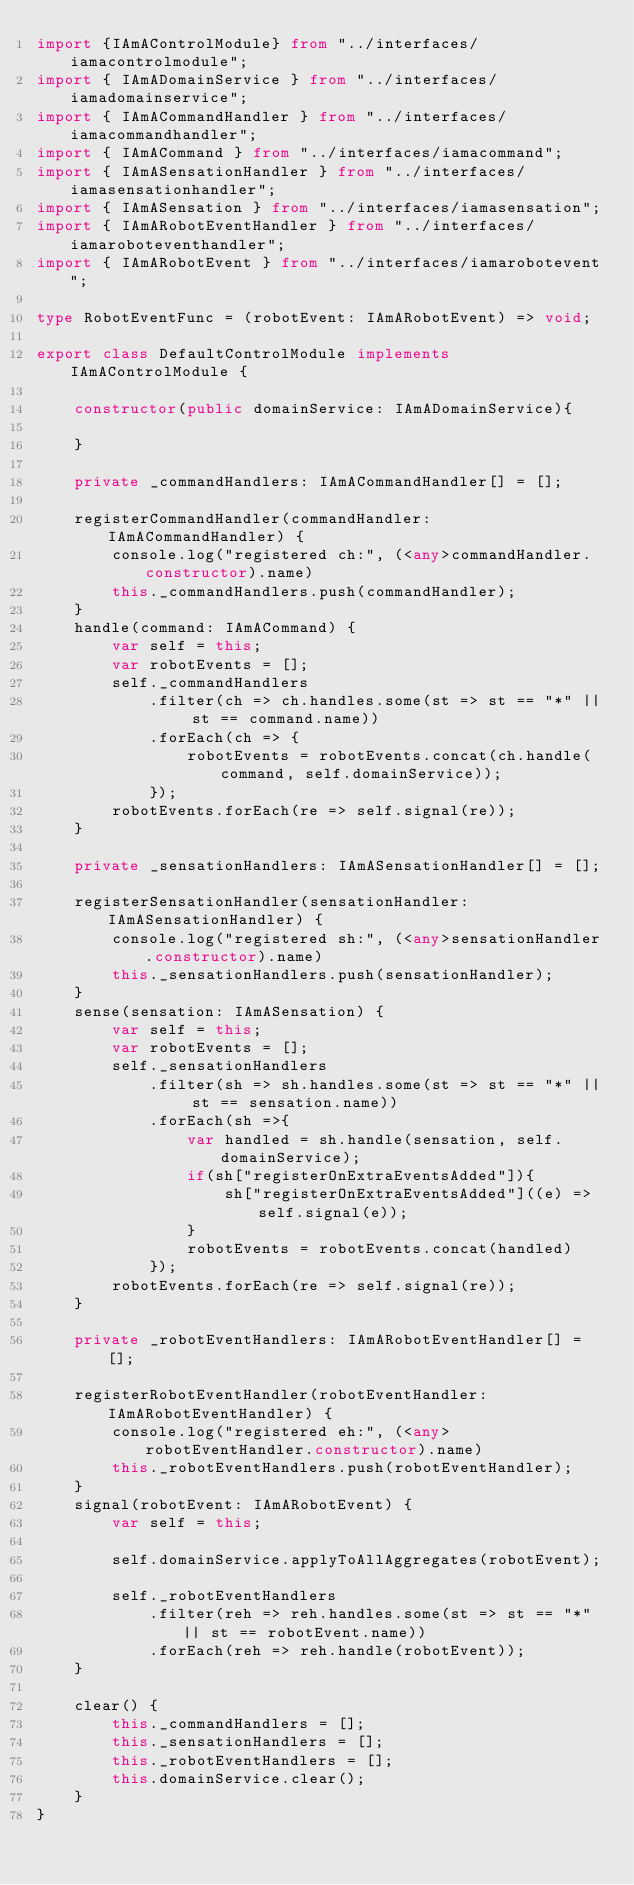Convert code to text. <code><loc_0><loc_0><loc_500><loc_500><_TypeScript_>import {IAmAControlModule} from "../interfaces/iamacontrolmodule";
import { IAmADomainService } from "../interfaces/iamadomainservice";
import { IAmACommandHandler } from "../interfaces/iamacommandhandler";
import { IAmACommand } from "../interfaces/iamacommand";
import { IAmASensationHandler } from "../interfaces/iamasensationhandler";
import { IAmASensation } from "../interfaces/iamasensation";
import { IAmARobotEventHandler } from "../interfaces/iamaroboteventhandler";
import { IAmARobotEvent } from "../interfaces/iamarobotevent";

type RobotEventFunc = (robotEvent: IAmARobotEvent) => void;

export class DefaultControlModule implements IAmAControlModule {
    
    constructor(public domainService: IAmADomainService){

    }

    private _commandHandlers: IAmACommandHandler[] = [];

    registerCommandHandler(commandHandler: IAmACommandHandler) {
        console.log("registered ch:", (<any>commandHandler.constructor).name)        
        this._commandHandlers.push(commandHandler);
    }
    handle(command: IAmACommand) {
        var self = this;
        var robotEvents = [];
        self._commandHandlers
            .filter(ch => ch.handles.some(st => st == "*" || st == command.name))
            .forEach(ch => {
                robotEvents = robotEvents.concat(ch.handle(command, self.domainService));
            });
        robotEvents.forEach(re => self.signal(re));        
    }

    private _sensationHandlers: IAmASensationHandler[] = [];

    registerSensationHandler(sensationHandler: IAmASensationHandler) {
        console.log("registered sh:", (<any>sensationHandler.constructor).name)        
        this._sensationHandlers.push(sensationHandler);
    }
    sense(sensation: IAmASensation) {
        var self = this;
        var robotEvents = [];
        self._sensationHandlers
            .filter(sh => sh.handles.some(st => st == "*" || st == sensation.name))
            .forEach(sh =>{
                var handled = sh.handle(sensation, self.domainService);
                if(sh["registerOnExtraEventsAdded"]){
                    sh["registerOnExtraEventsAdded"]((e) => self.signal(e));            
                }
                robotEvents = robotEvents.concat(handled)
            });
        robotEvents.forEach(re => self.signal(re));
    }

    private _robotEventHandlers: IAmARobotEventHandler[] = [];

    registerRobotEventHandler(robotEventHandler: IAmARobotEventHandler) {
        console.log("registered eh:", (<any>robotEventHandler.constructor).name)
        this._robotEventHandlers.push(robotEventHandler);
    }
    signal(robotEvent: IAmARobotEvent) {
        var self = this;

        self.domainService.applyToAllAggregates(robotEvent);

        self._robotEventHandlers
            .filter(reh => reh.handles.some(st => st == "*" || st == robotEvent.name))
            .forEach(reh => reh.handle(robotEvent));        
    }

    clear() {
        this._commandHandlers = [];
        this._sensationHandlers = [];
        this._robotEventHandlers = [];
        this.domainService.clear();
    }
}</code> 